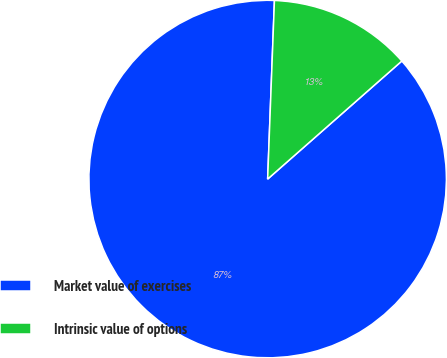<chart> <loc_0><loc_0><loc_500><loc_500><pie_chart><fcel>Market value of exercises<fcel>Intrinsic value of options<nl><fcel>87.09%<fcel>12.91%<nl></chart> 